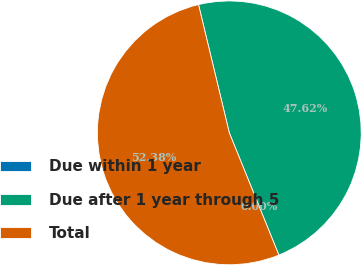Convert chart. <chart><loc_0><loc_0><loc_500><loc_500><pie_chart><fcel>Due within 1 year<fcel>Due after 1 year through 5<fcel>Total<nl><fcel>0.0%<fcel>47.62%<fcel>52.38%<nl></chart> 